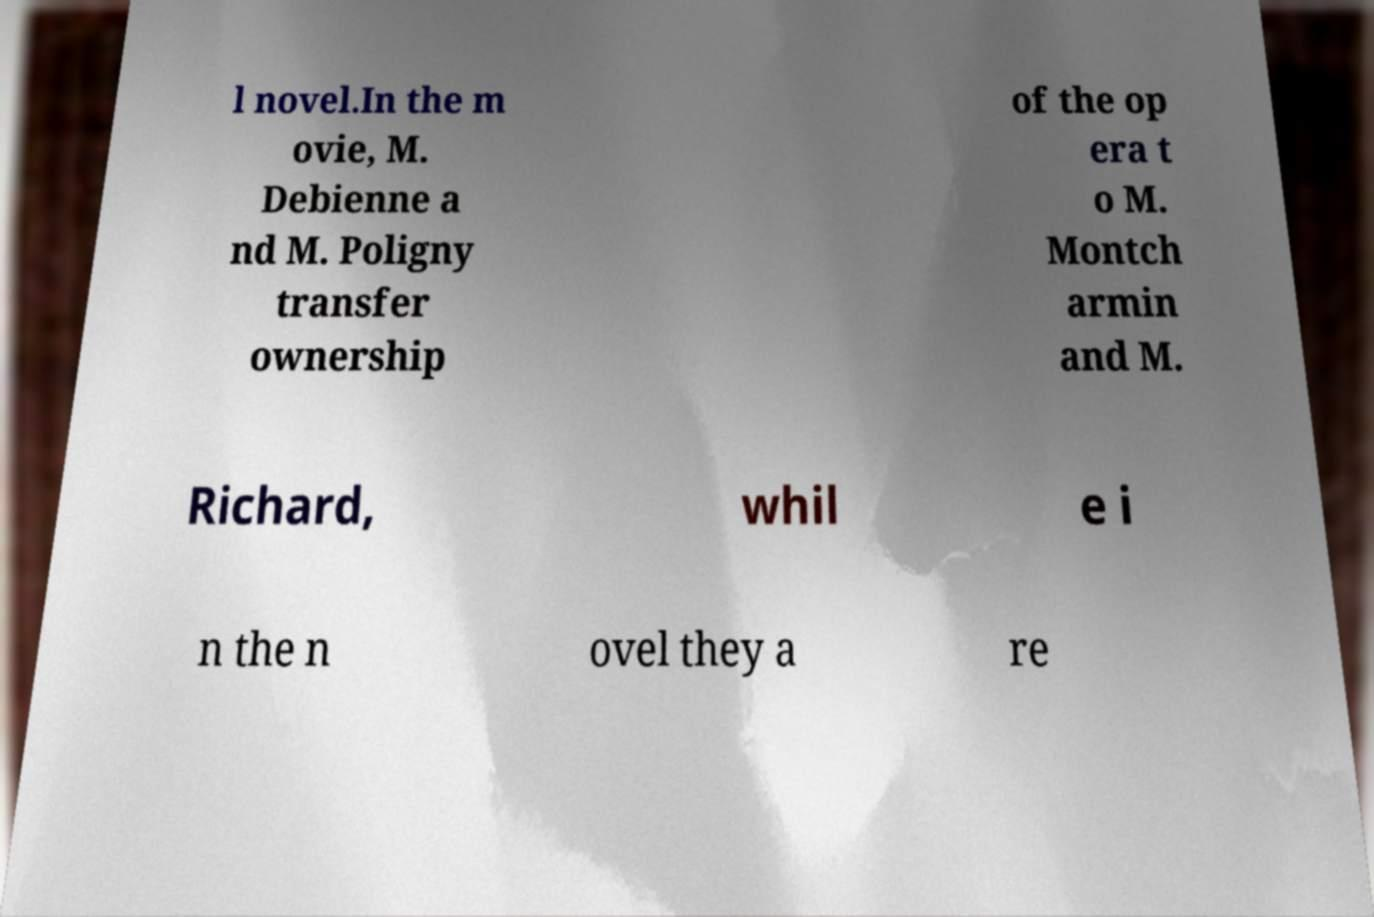There's text embedded in this image that I need extracted. Can you transcribe it verbatim? l novel.In the m ovie, M. Debienne a nd M. Poligny transfer ownership of the op era t o M. Montch armin and M. Richard, whil e i n the n ovel they a re 